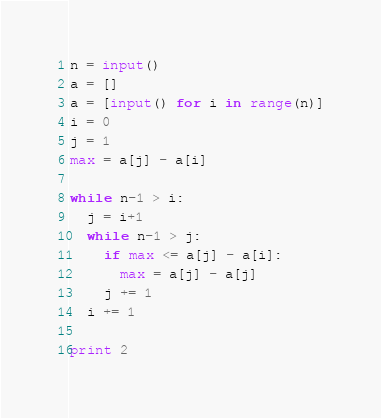Convert code to text. <code><loc_0><loc_0><loc_500><loc_500><_Python_>n = input()
a = []
a = [input() for i in range(n)]
i = 0
j = 1
max = a[j] - a[i]

while n-1 > i:
  j = i+1
  while n-1 > j:
    if max <= a[j] - a[i]:
      max = a[j] - a[j]
    j += 1
  i += 1

print 2</code> 